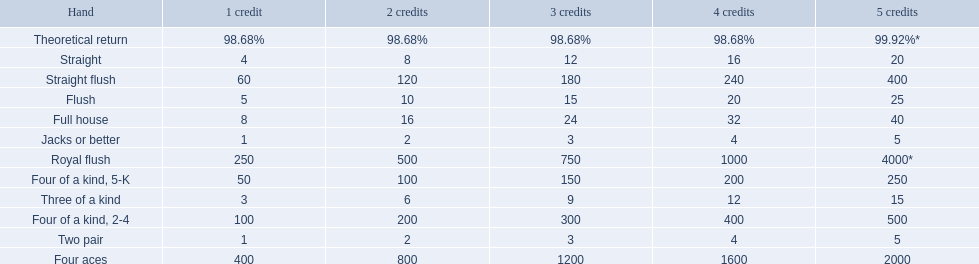What are each of the hands? Royal flush, Straight flush, Four aces, Four of a kind, 2-4, Four of a kind, 5-K, Full house, Flush, Straight, Three of a kind, Two pair, Jacks or better, Theoretical return. Which hand ranks higher between straights and flushes? Flush. 